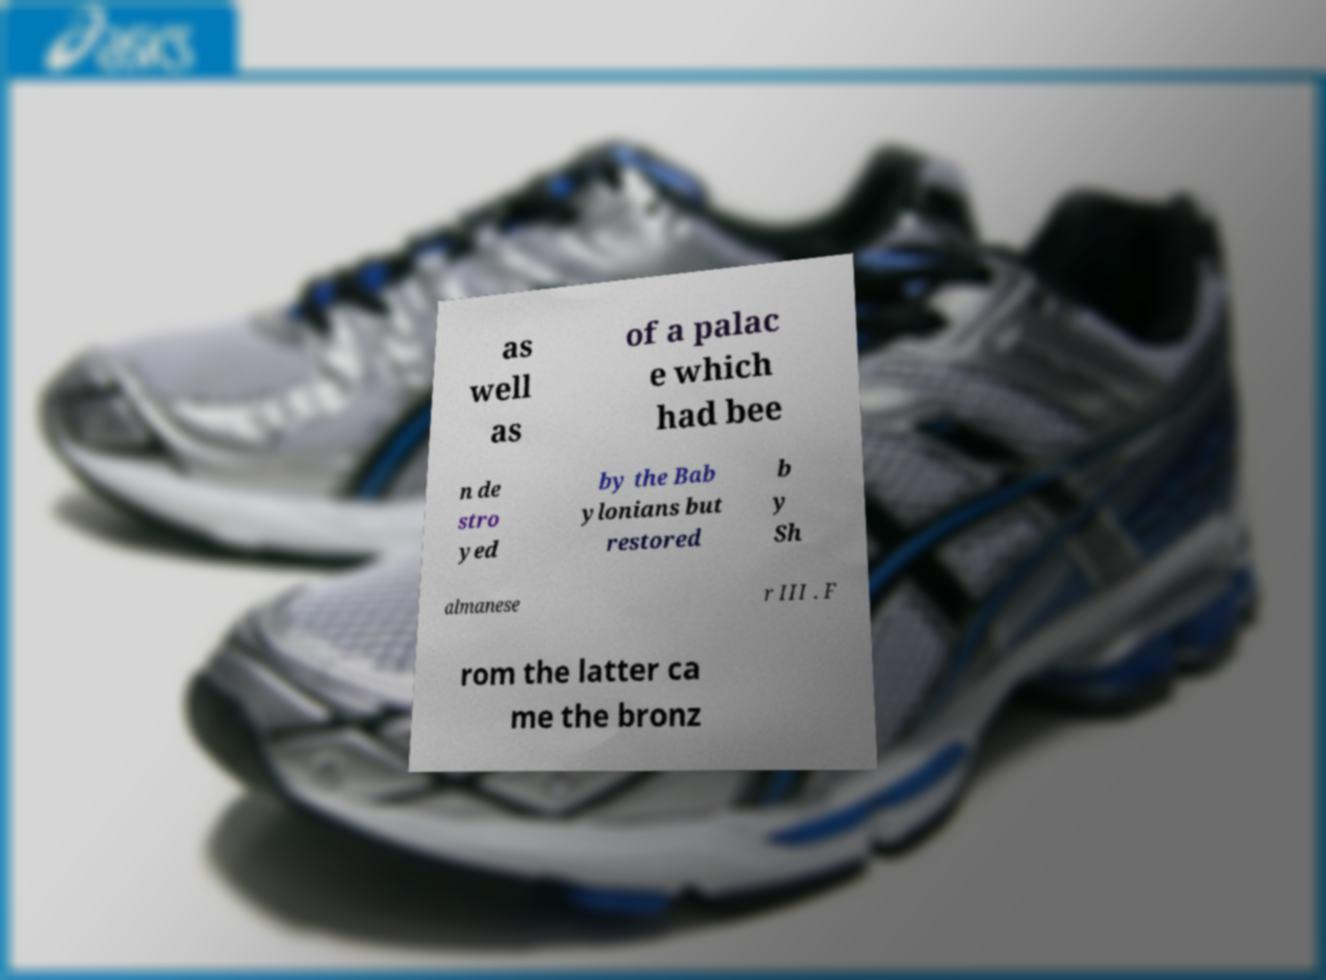For documentation purposes, I need the text within this image transcribed. Could you provide that? as well as of a palac e which had bee n de stro yed by the Bab ylonians but restored b y Sh almanese r III . F rom the latter ca me the bronz 